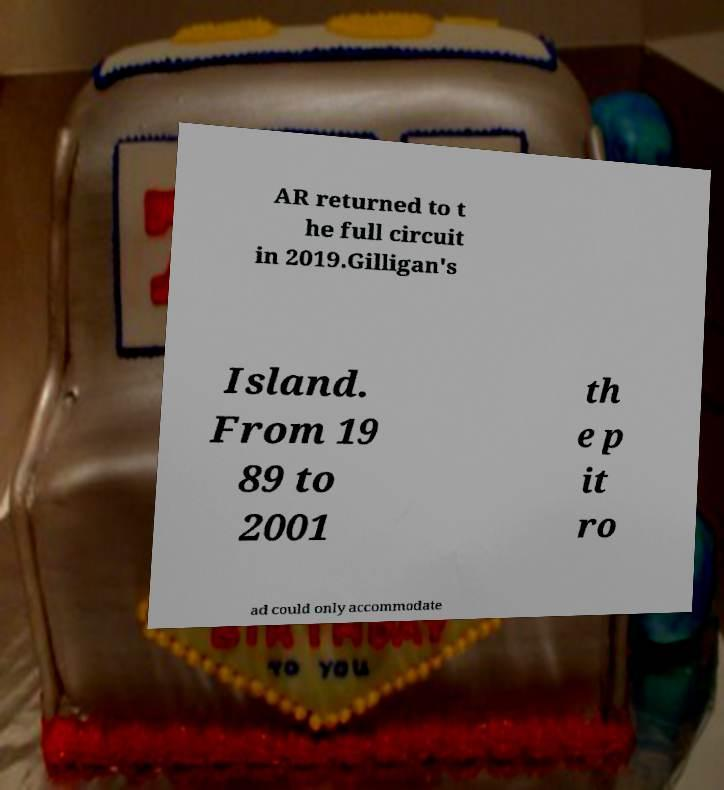There's text embedded in this image that I need extracted. Can you transcribe it verbatim? AR returned to t he full circuit in 2019.Gilligan's Island. From 19 89 to 2001 th e p it ro ad could only accommodate 